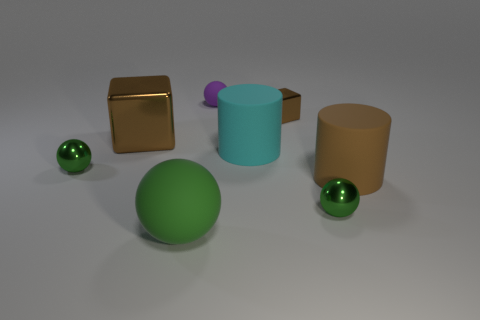Subtract all purple blocks. How many green balls are left? 3 Add 2 small matte spheres. How many objects exist? 10 Subtract all cylinders. How many objects are left? 6 Subtract 0 cyan spheres. How many objects are left? 8 Subtract all brown cylinders. Subtract all green spheres. How many objects are left? 4 Add 8 large green matte spheres. How many large green matte spheres are left? 9 Add 7 large cylinders. How many large cylinders exist? 9 